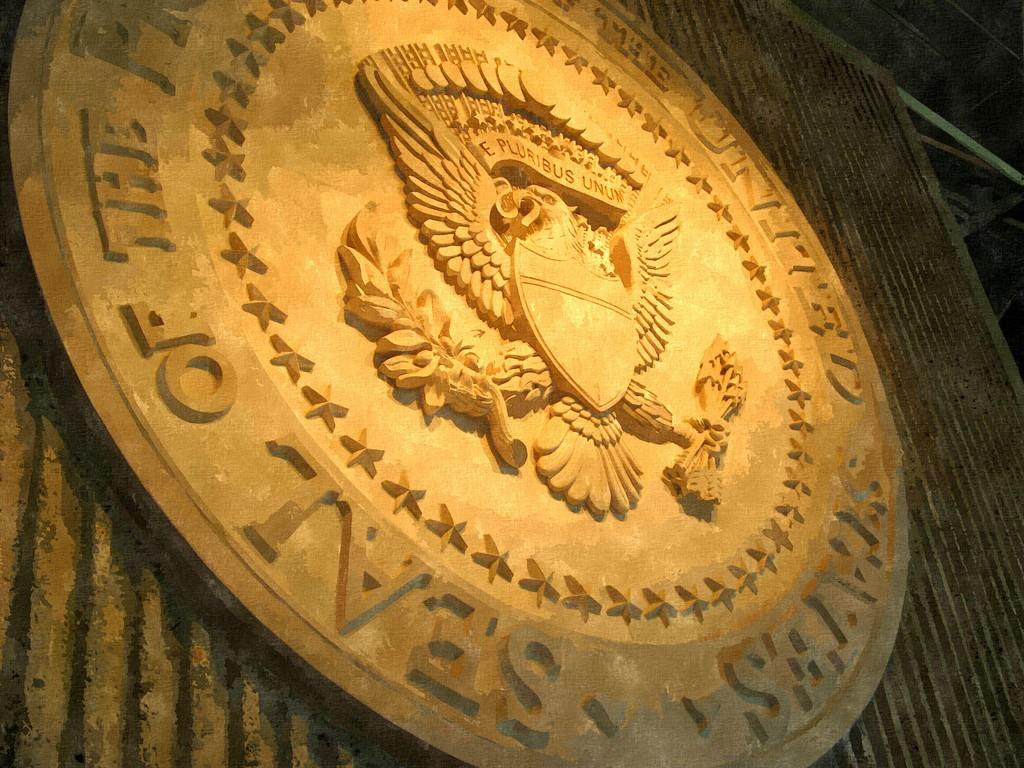<image>
Offer a succinct explanation of the picture presented. A very large wall emblem of the Seal of the President of the United States. 